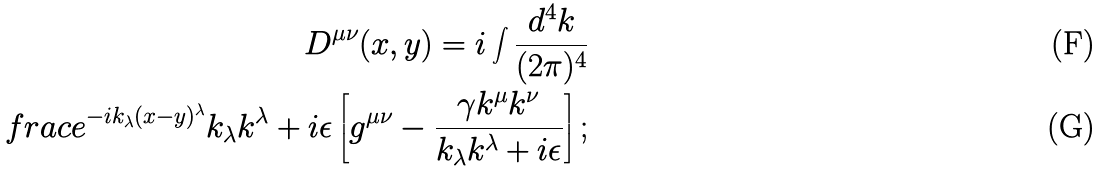Convert formula to latex. <formula><loc_0><loc_0><loc_500><loc_500>D ^ { \mu \nu } ( x , y ) = i \int \frac { d ^ { 4 } k } { ( 2 \pi ) ^ { 4 } } \\ f r a c { e ^ { - i k _ { \lambda } ( x - y ) ^ { \lambda } } } { k _ { \lambda } k ^ { \lambda } + i \epsilon } \left [ g ^ { \mu \nu } - \frac { \gamma k ^ { \mu } k ^ { \nu } } { k _ { \lambda } k ^ { \lambda } + i \epsilon } \right ] ;</formula> 